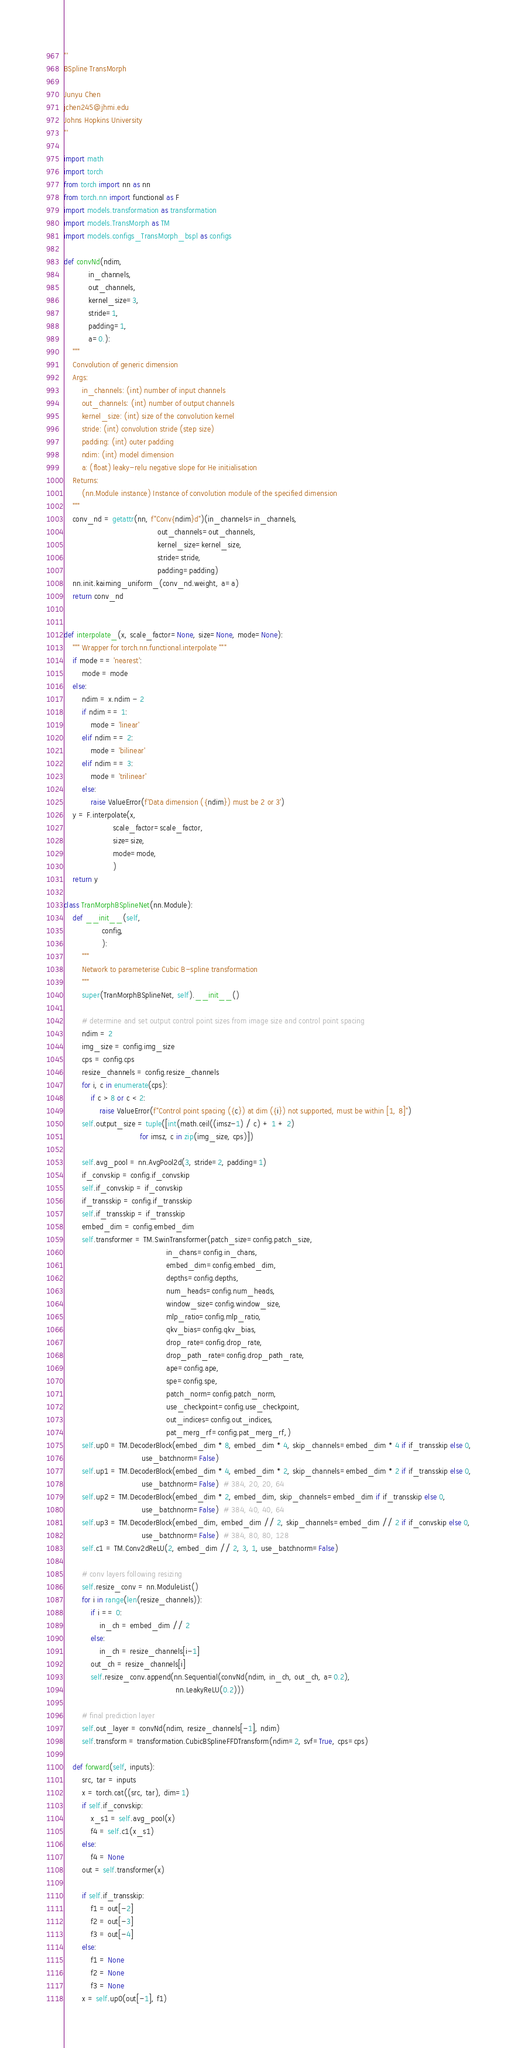<code> <loc_0><loc_0><loc_500><loc_500><_Python_>'''
BSpline TransMorph

Junyu Chen
jchen245@jhmi.edu
Johns Hopkins University
'''

import math
import torch
from torch import nn as nn
from torch.nn import functional as F
import models.transformation as transformation
import models.TransMorph as TM
import models.configs_TransMorph_bspl as configs

def convNd(ndim,
           in_channels,
           out_channels,
           kernel_size=3,
           stride=1,
           padding=1,
           a=0.):
    """
    Convolution of generic dimension
    Args:
        in_channels: (int) number of input channels
        out_channels: (int) number of output channels
        kernel_size: (int) size of the convolution kernel
        stride: (int) convolution stride (step size)
        padding: (int) outer padding
        ndim: (int) model dimension
        a: (float) leaky-relu negative slope for He initialisation
    Returns:
        (nn.Module instance) Instance of convolution module of the specified dimension
    """
    conv_nd = getattr(nn, f"Conv{ndim}d")(in_channels=in_channels,
                                          out_channels=out_channels,
                                          kernel_size=kernel_size,
                                          stride=stride,
                                          padding=padding)
    nn.init.kaiming_uniform_(conv_nd.weight, a=a)
    return conv_nd


def interpolate_(x, scale_factor=None, size=None, mode=None):
    """ Wrapper for torch.nn.functional.interpolate """
    if mode == 'nearest':
        mode = mode
    else:
        ndim = x.ndim - 2
        if ndim == 1:
            mode = 'linear'
        elif ndim == 2:
            mode = 'bilinear'
        elif ndim == 3:
            mode = 'trilinear'
        else:
            raise ValueError(f'Data dimension ({ndim}) must be 2 or 3')
    y = F.interpolate(x,
                      scale_factor=scale_factor,
                      size=size,
                      mode=mode,
                      )
    return y

class TranMorphBSplineNet(nn.Module):
    def __init__(self,
                 config,
                 ):
        """
        Network to parameterise Cubic B-spline transformation
        """
        super(TranMorphBSplineNet, self).__init__()

        # determine and set output control point sizes from image size and control point spacing
        ndim = 2
        img_size = config.img_size
        cps = config.cps
        resize_channels = config.resize_channels
        for i, c in enumerate(cps):
            if c > 8 or c < 2:
                raise ValueError(f"Control point spacing ({c}) at dim ({i}) not supported, must be within [1, 8]")
        self.output_size = tuple([int(math.ceil((imsz-1) / c) + 1 + 2)
                                  for imsz, c in zip(img_size, cps)])

        self.avg_pool = nn.AvgPool2d(3, stride=2, padding=1)
        if_convskip = config.if_convskip
        self.if_convskip = if_convskip
        if_transskip = config.if_transskip
        self.if_transskip = if_transskip
        embed_dim = config.embed_dim
        self.transformer = TM.SwinTransformer(patch_size=config.patch_size,
                                              in_chans=config.in_chans,
                                              embed_dim=config.embed_dim,
                                              depths=config.depths,
                                              num_heads=config.num_heads,
                                              window_size=config.window_size,
                                              mlp_ratio=config.mlp_ratio,
                                              qkv_bias=config.qkv_bias,
                                              drop_rate=config.drop_rate,
                                              drop_path_rate=config.drop_path_rate,
                                              ape=config.ape,
                                              spe=config.spe,
                                              patch_norm=config.patch_norm,
                                              use_checkpoint=config.use_checkpoint,
                                              out_indices=config.out_indices,
                                              pat_merg_rf=config.pat_merg_rf,)
        self.up0 = TM.DecoderBlock(embed_dim * 8, embed_dim * 4, skip_channels=embed_dim * 4 if if_transskip else 0,
                                   use_batchnorm=False)
        self.up1 = TM.DecoderBlock(embed_dim * 4, embed_dim * 2, skip_channels=embed_dim * 2 if if_transskip else 0,
                                   use_batchnorm=False)  # 384, 20, 20, 64
        self.up2 = TM.DecoderBlock(embed_dim * 2, embed_dim, skip_channels=embed_dim if if_transskip else 0,
                                   use_batchnorm=False)  # 384, 40, 40, 64
        self.up3 = TM.DecoderBlock(embed_dim, embed_dim // 2, skip_channels=embed_dim // 2 if if_convskip else 0,
                                   use_batchnorm=False)  # 384, 80, 80, 128
        self.c1 = TM.Conv2dReLU(2, embed_dim // 2, 3, 1, use_batchnorm=False)

        # conv layers following resizing
        self.resize_conv = nn.ModuleList()
        for i in range(len(resize_channels)):
            if i == 0:
                in_ch = embed_dim // 2
            else:
                in_ch = resize_channels[i-1]
            out_ch = resize_channels[i]
            self.resize_conv.append(nn.Sequential(convNd(ndim, in_ch, out_ch, a=0.2),
                                                  nn.LeakyReLU(0.2)))

        # final prediction layer
        self.out_layer = convNd(ndim, resize_channels[-1], ndim)
        self.transform = transformation.CubicBSplineFFDTransform(ndim=2, svf=True, cps=cps)

    def forward(self, inputs):
        src, tar = inputs
        x = torch.cat((src, tar), dim=1)
        if self.if_convskip:
            x_s1 = self.avg_pool(x)
            f4 = self.c1(x_s1)
        else:
            f4 = None
        out = self.transformer(x)

        if self.if_transskip:
            f1 = out[-2]
            f2 = out[-3]
            f3 = out[-4]
        else:
            f1 = None
            f2 = None
            f3 = None
        x = self.up0(out[-1], f1)</code> 